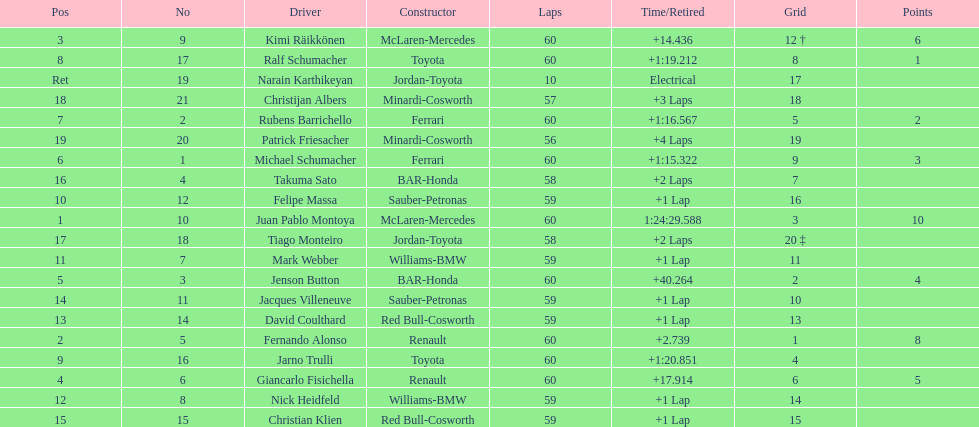After 8th position, how many points does a driver receive? 0. 